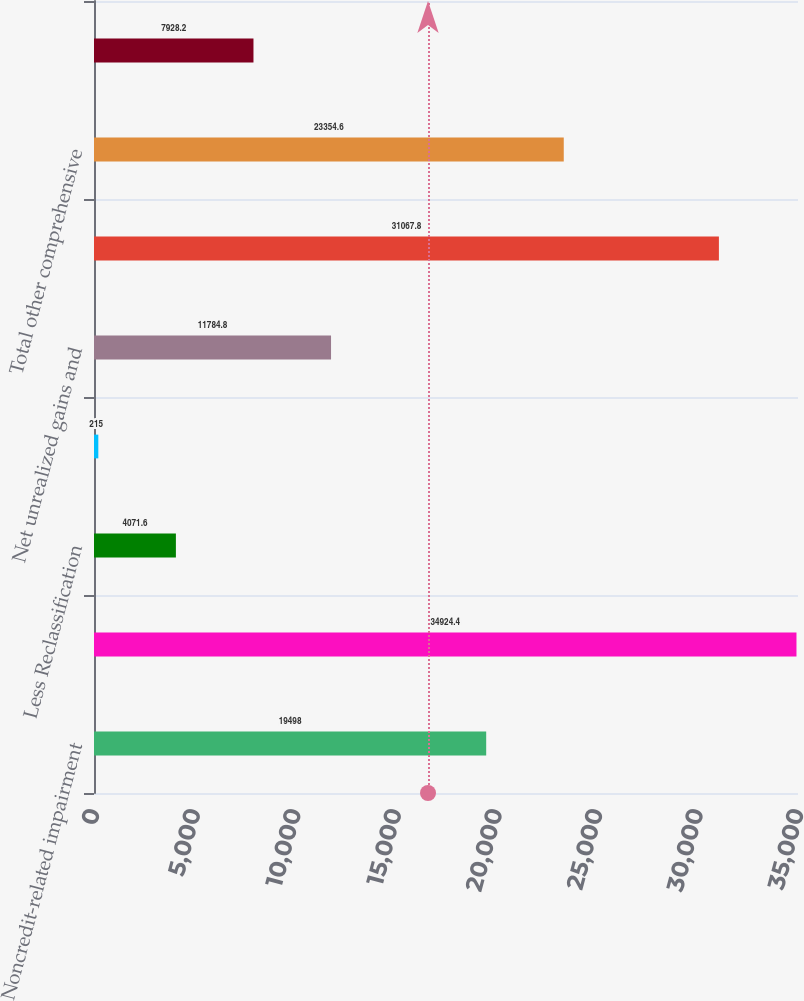<chart> <loc_0><loc_0><loc_500><loc_500><bar_chart><fcel>Noncredit-related impairment<fcel>Unrealized holding gains<fcel>Less Reclassification<fcel>Net change in unrealized<fcel>Net unrealized gains and<fcel>Change in pension and<fcel>Total other comprehensive<fcel>Cumulative effect of change in<nl><fcel>19498<fcel>34924.4<fcel>4071.6<fcel>215<fcel>11784.8<fcel>31067.8<fcel>23354.6<fcel>7928.2<nl></chart> 